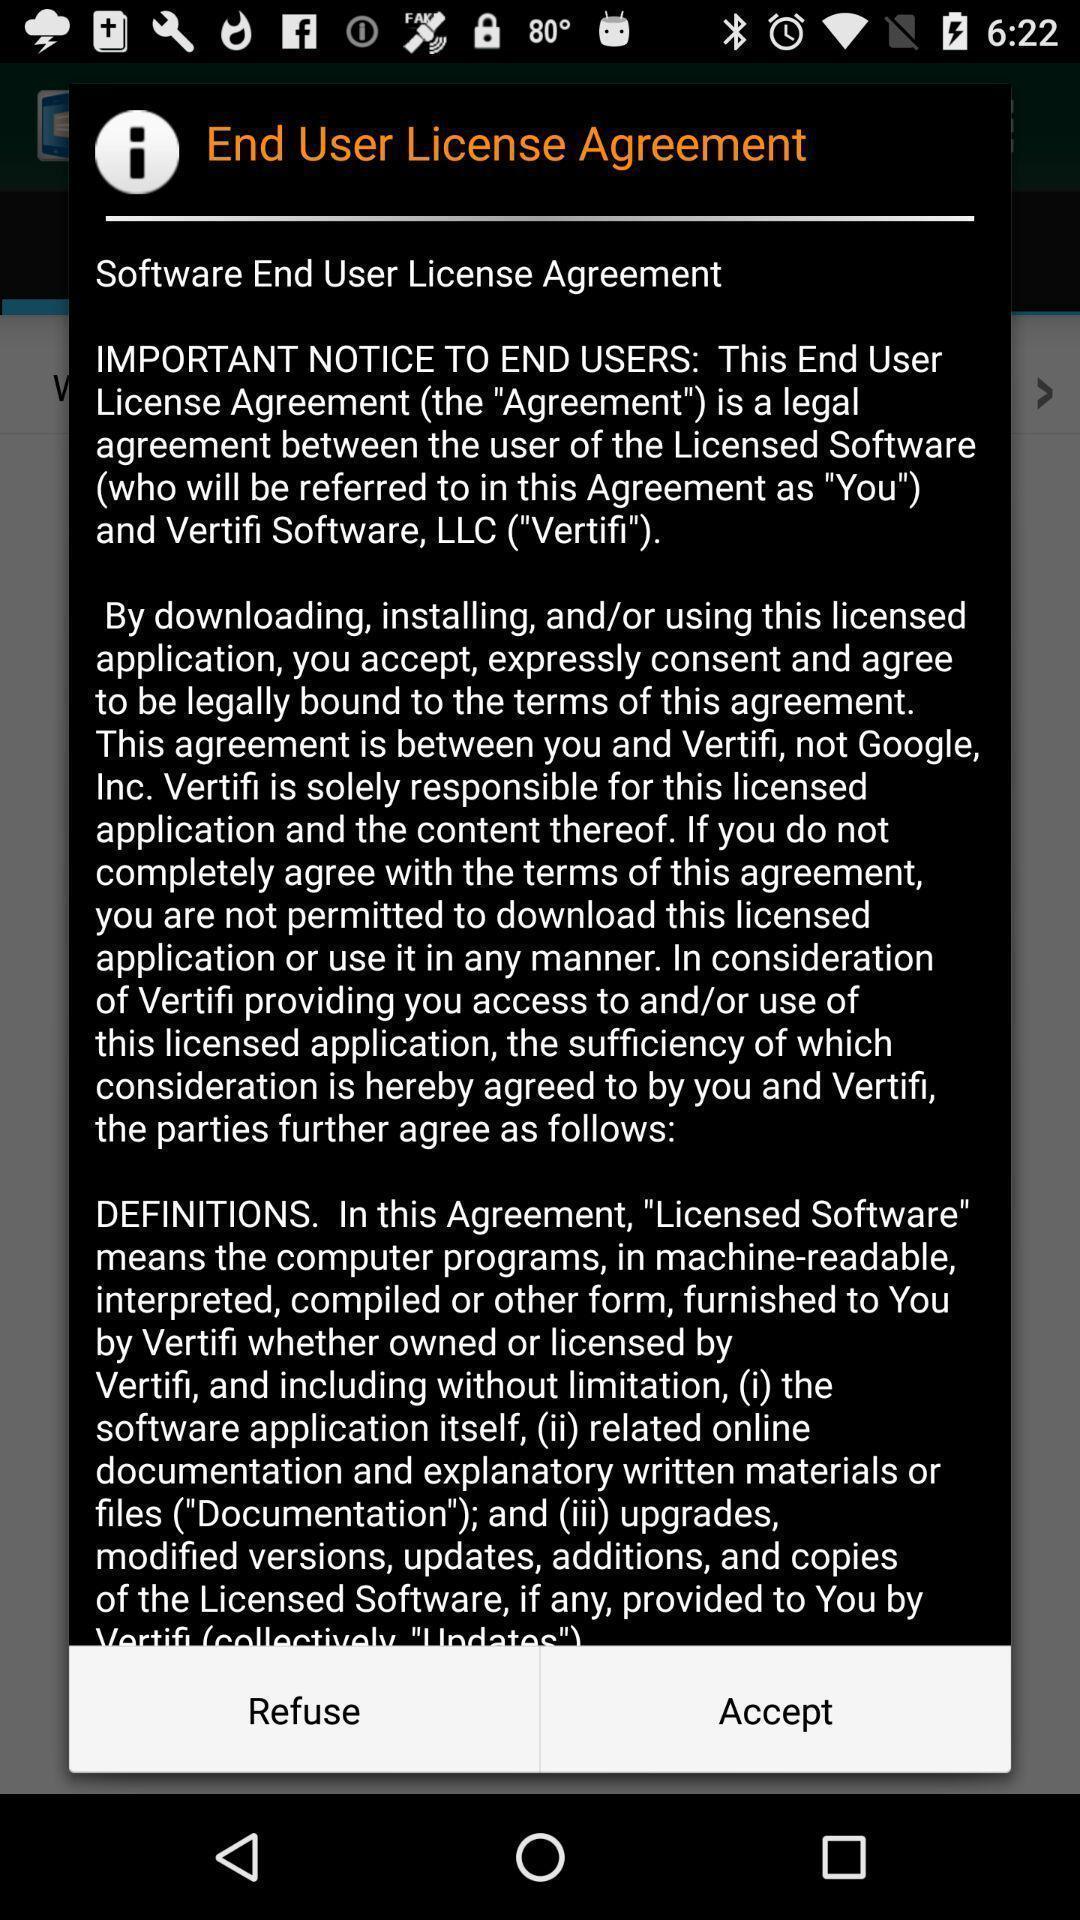Give me a summary of this screen capture. Popup showing a license agreement. 